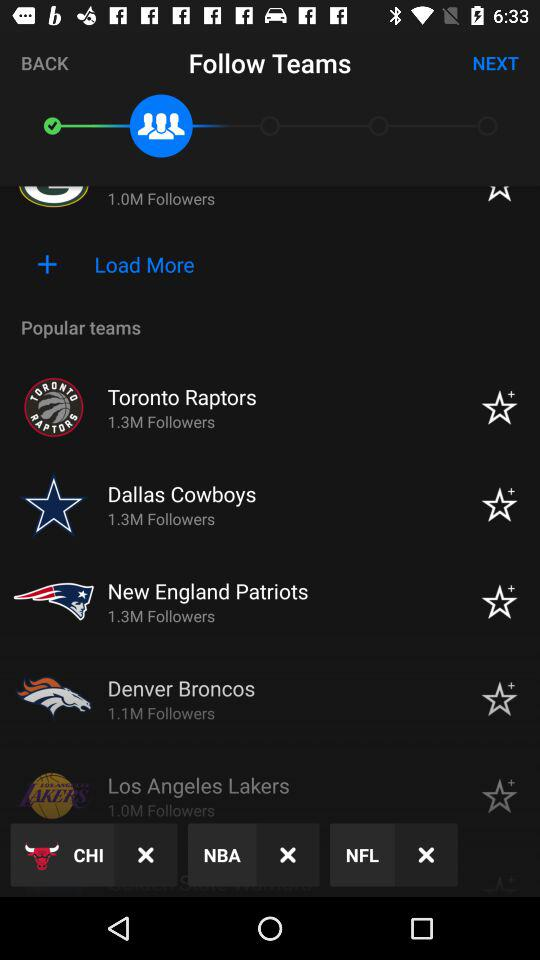How many followers are there for the "Los Angeles Lakers"? The "Los Angeles Lakers" have 1.0 million followers. 